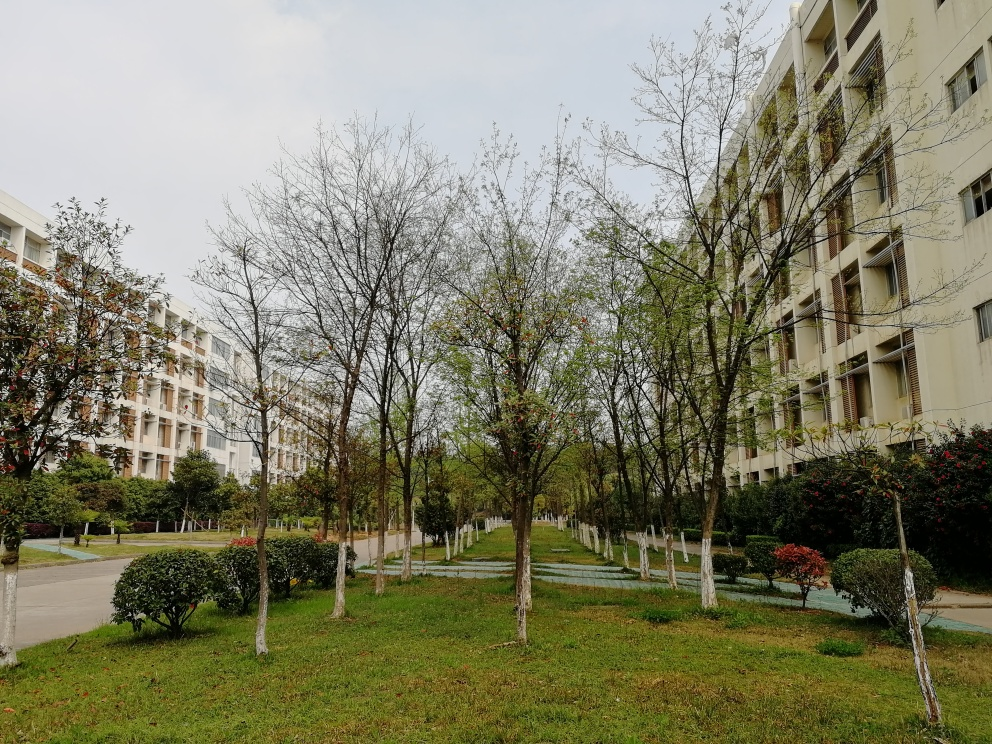What could improve the composition of this photo? To improve the composition, the photographer could employ the rule of thirds by adjusting the angle to position a focal point off-center. Additionally, finding a perspective that includes a dynamic element, such as a person walking down the path or using a lower angle to make the trees appear more imposing, could add interest to the photo. 